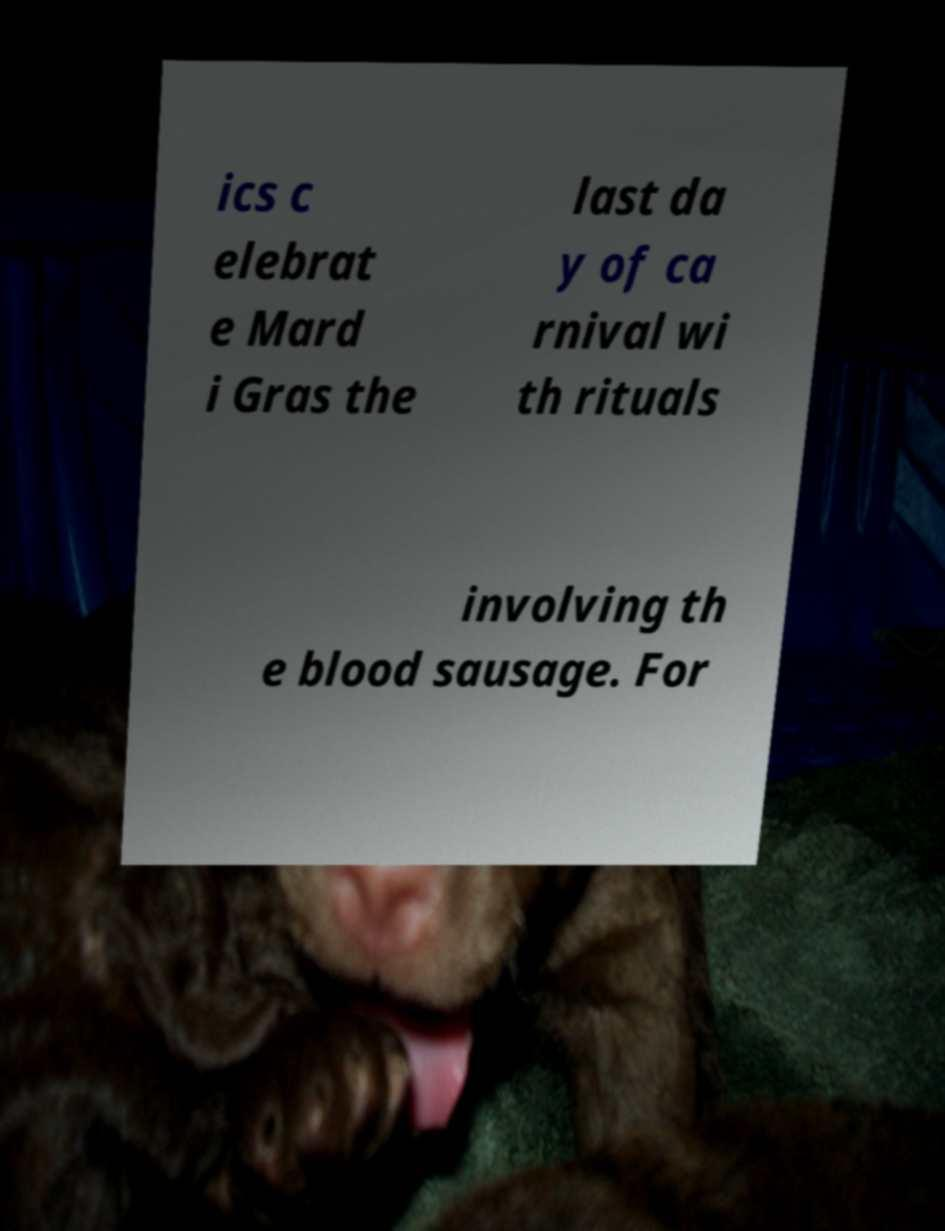Please identify and transcribe the text found in this image. ics c elebrat e Mard i Gras the last da y of ca rnival wi th rituals involving th e blood sausage. For 